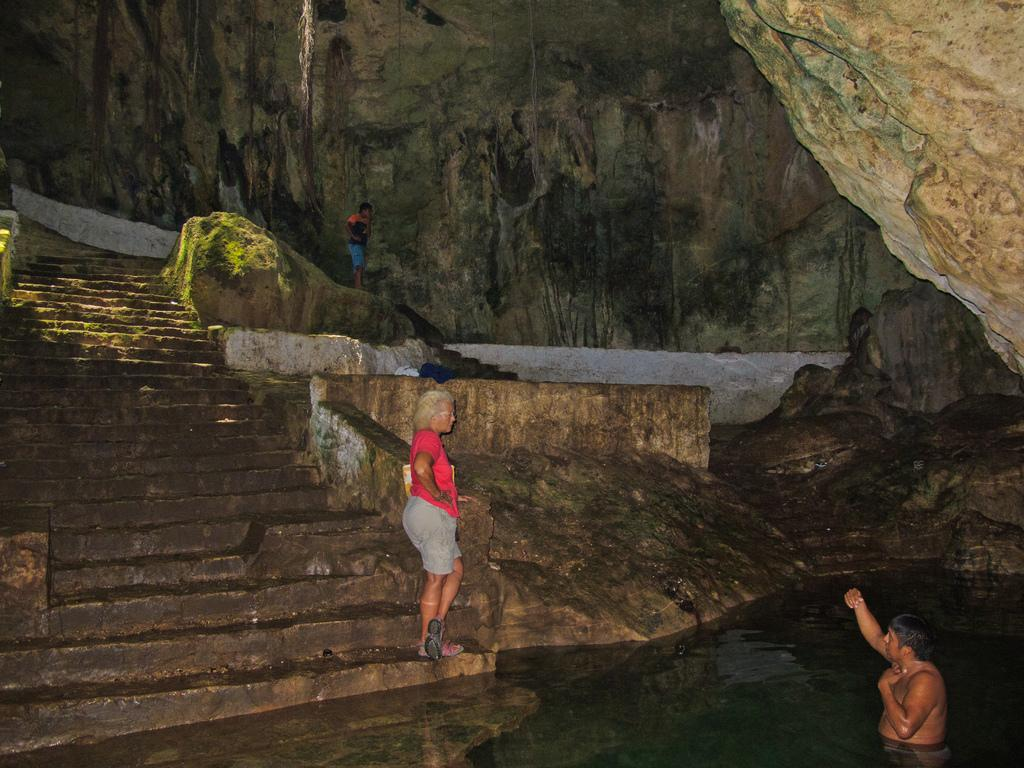What is the person in the image doing? There is a person standing on the steps and another person in the water. What can be seen in the background of the image? There are rocks visible in the background. How many people are present in the image? There are two people present in the image. What type of stone is the sheep holding in the image? There is no sheep or stone present in the image. How many gloves can be seen on the person standing on the steps? There are no gloves visible on the person standing on the steps in the image. 